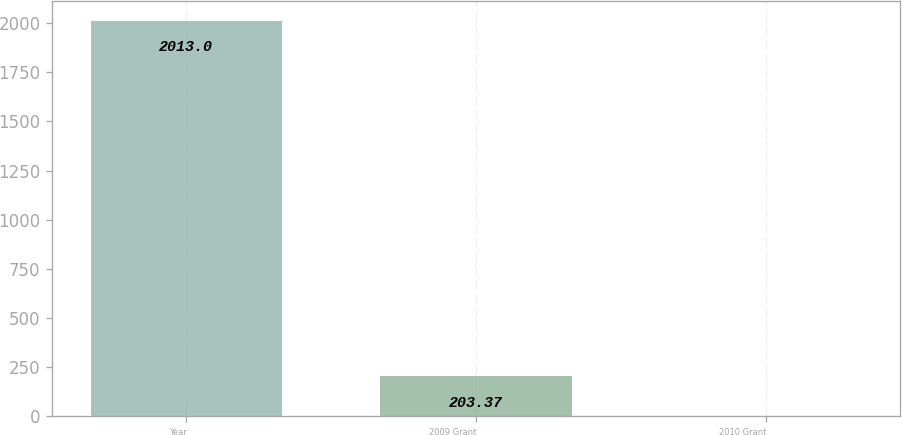Convert chart to OTSL. <chart><loc_0><loc_0><loc_500><loc_500><bar_chart><fcel>Year<fcel>2009 Grant<fcel>2010 Grant<nl><fcel>2013<fcel>203.37<fcel>2.3<nl></chart> 